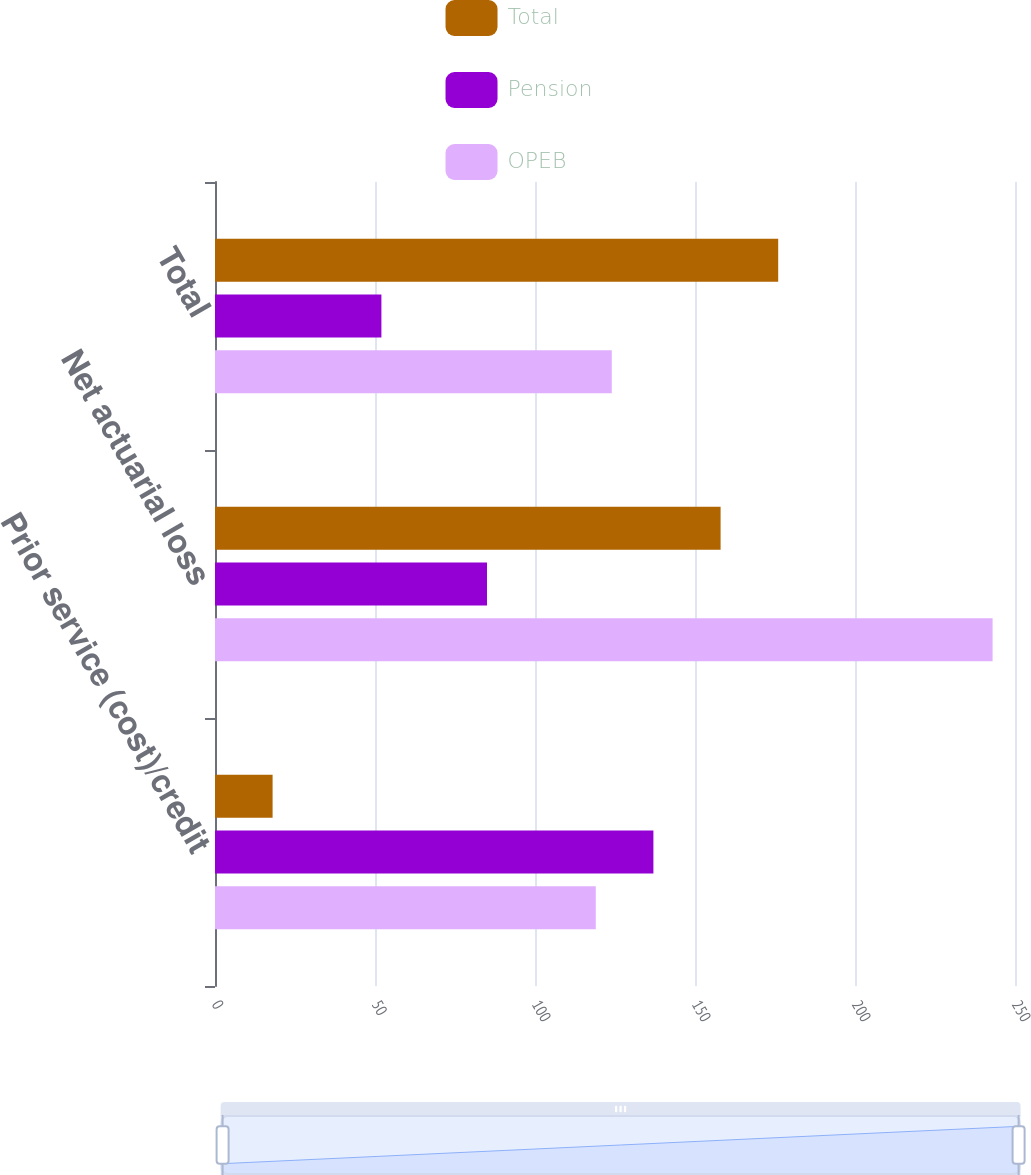<chart> <loc_0><loc_0><loc_500><loc_500><stacked_bar_chart><ecel><fcel>Prior service (cost)/credit<fcel>Net actuarial loss<fcel>Total<nl><fcel>Total<fcel>18<fcel>158<fcel>176<nl><fcel>Pension<fcel>137<fcel>85<fcel>52<nl><fcel>OPEB<fcel>119<fcel>243<fcel>124<nl></chart> 